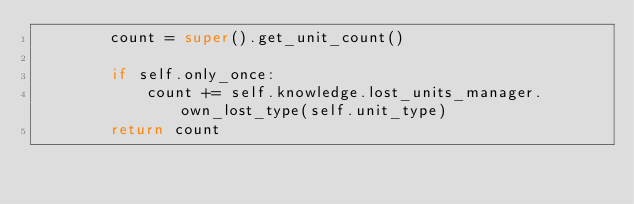<code> <loc_0><loc_0><loc_500><loc_500><_Python_>        count = super().get_unit_count()

        if self.only_once:
            count += self.knowledge.lost_units_manager.own_lost_type(self.unit_type)
        return count
</code> 